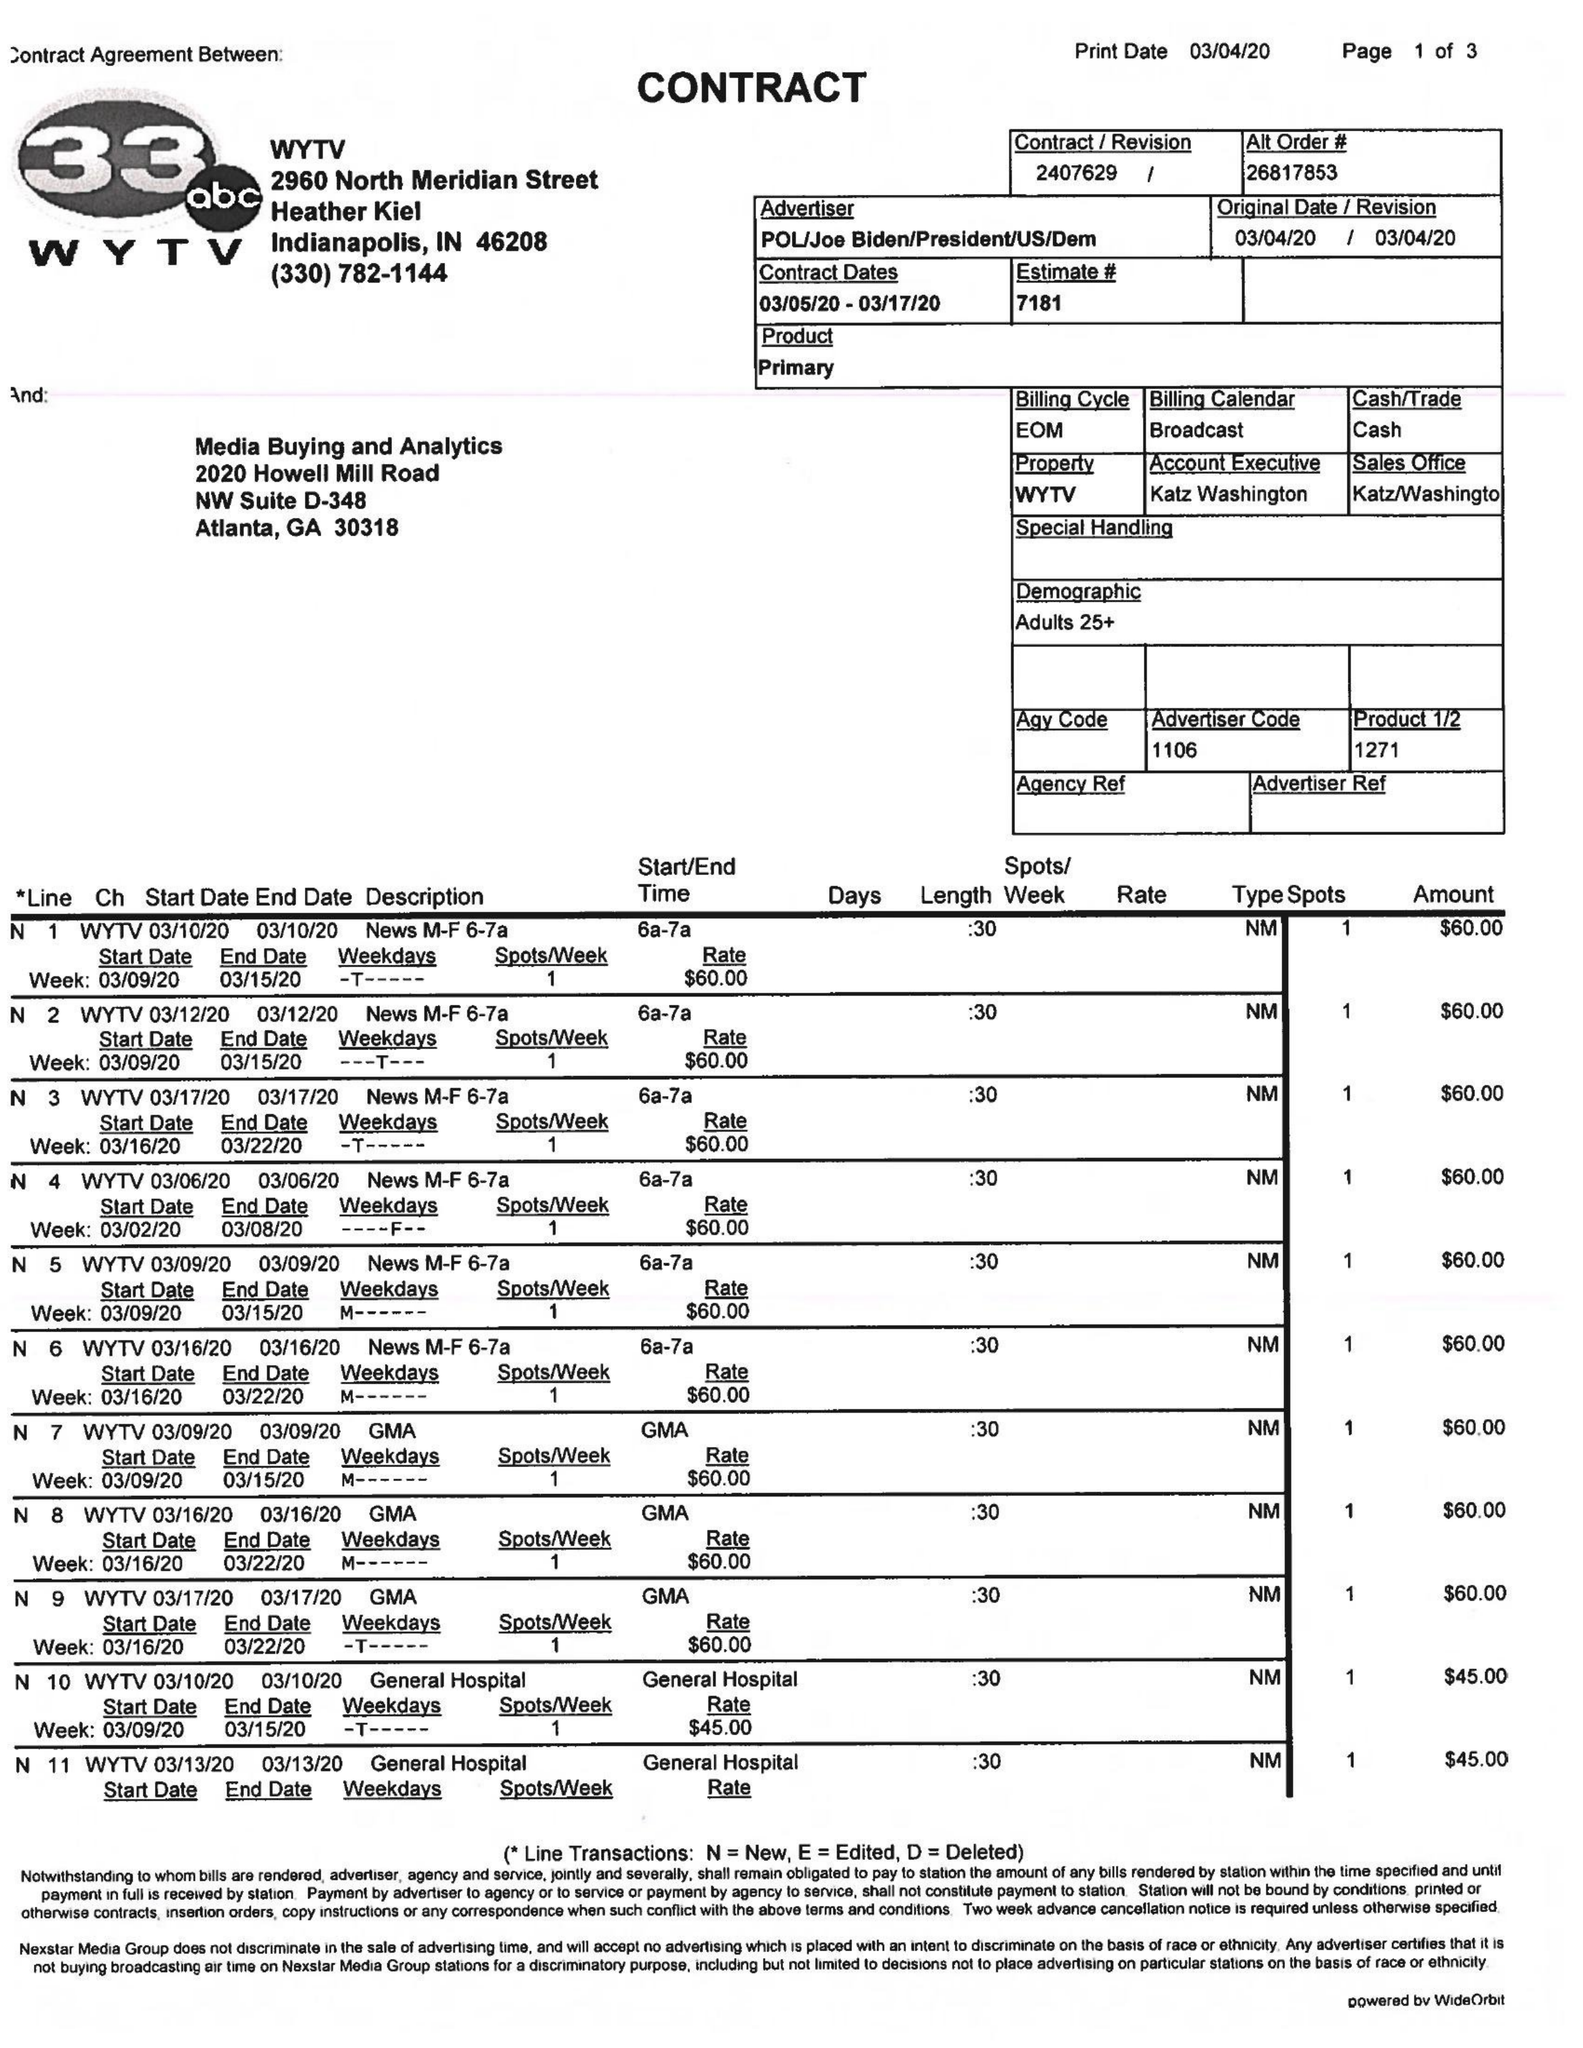What is the value for the flight_to?
Answer the question using a single word or phrase. 03/17/20 